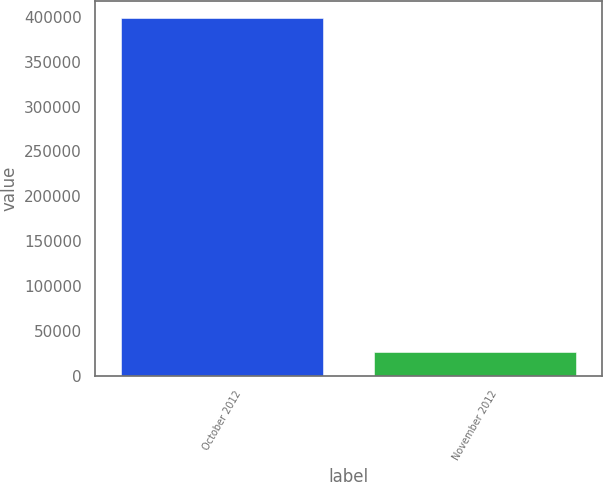Convert chart to OTSL. <chart><loc_0><loc_0><loc_500><loc_500><bar_chart><fcel>October 2012<fcel>November 2012<nl><fcel>398131<fcel>26100<nl></chart> 